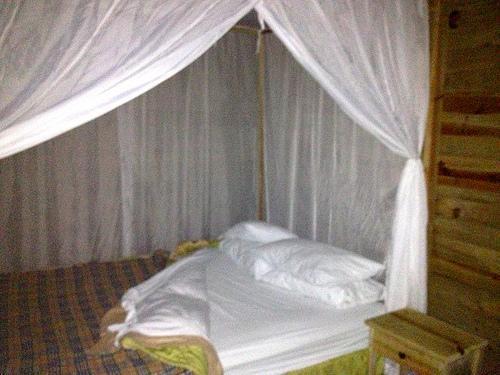How many pillows are there?
Give a very brief answer. 4. How many blankets are on the bed?
Give a very brief answer. 2. How many drawers in nightstand?
Give a very brief answer. 1. 